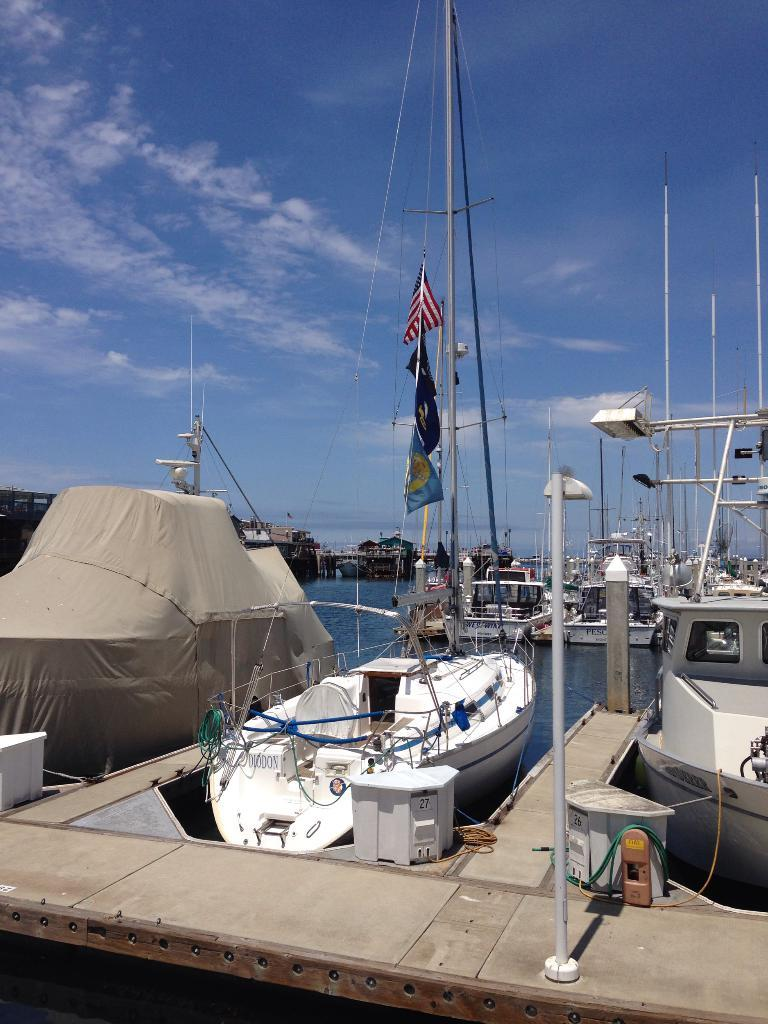What type of vehicles can be seen in the image? There are boats in the image. What structures are present in the image? There are poles, flags, ropes, buildings, and boats in the image. What natural elements can be seen in the image? There is water, sky, and clouds visible in the image. What type of pencil can be seen in the image? There is no pencil present in the image. What statement can be made about the experience of the people in the image? There is no information about the people's experience in the image. 